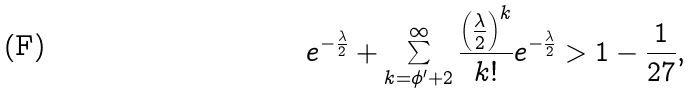Convert formula to latex. <formula><loc_0><loc_0><loc_500><loc_500>e ^ { - \frac { \lambda } { 2 } } + \sum _ { k = \phi ^ { \prime } + 2 } ^ { \infty } \frac { \left ( \frac { \lambda } { 2 } \right ) ^ { k } } { k ! } e ^ { - \frac { \lambda } { 2 } } > 1 - { \frac { 1 } { 2 7 } } ,</formula> 